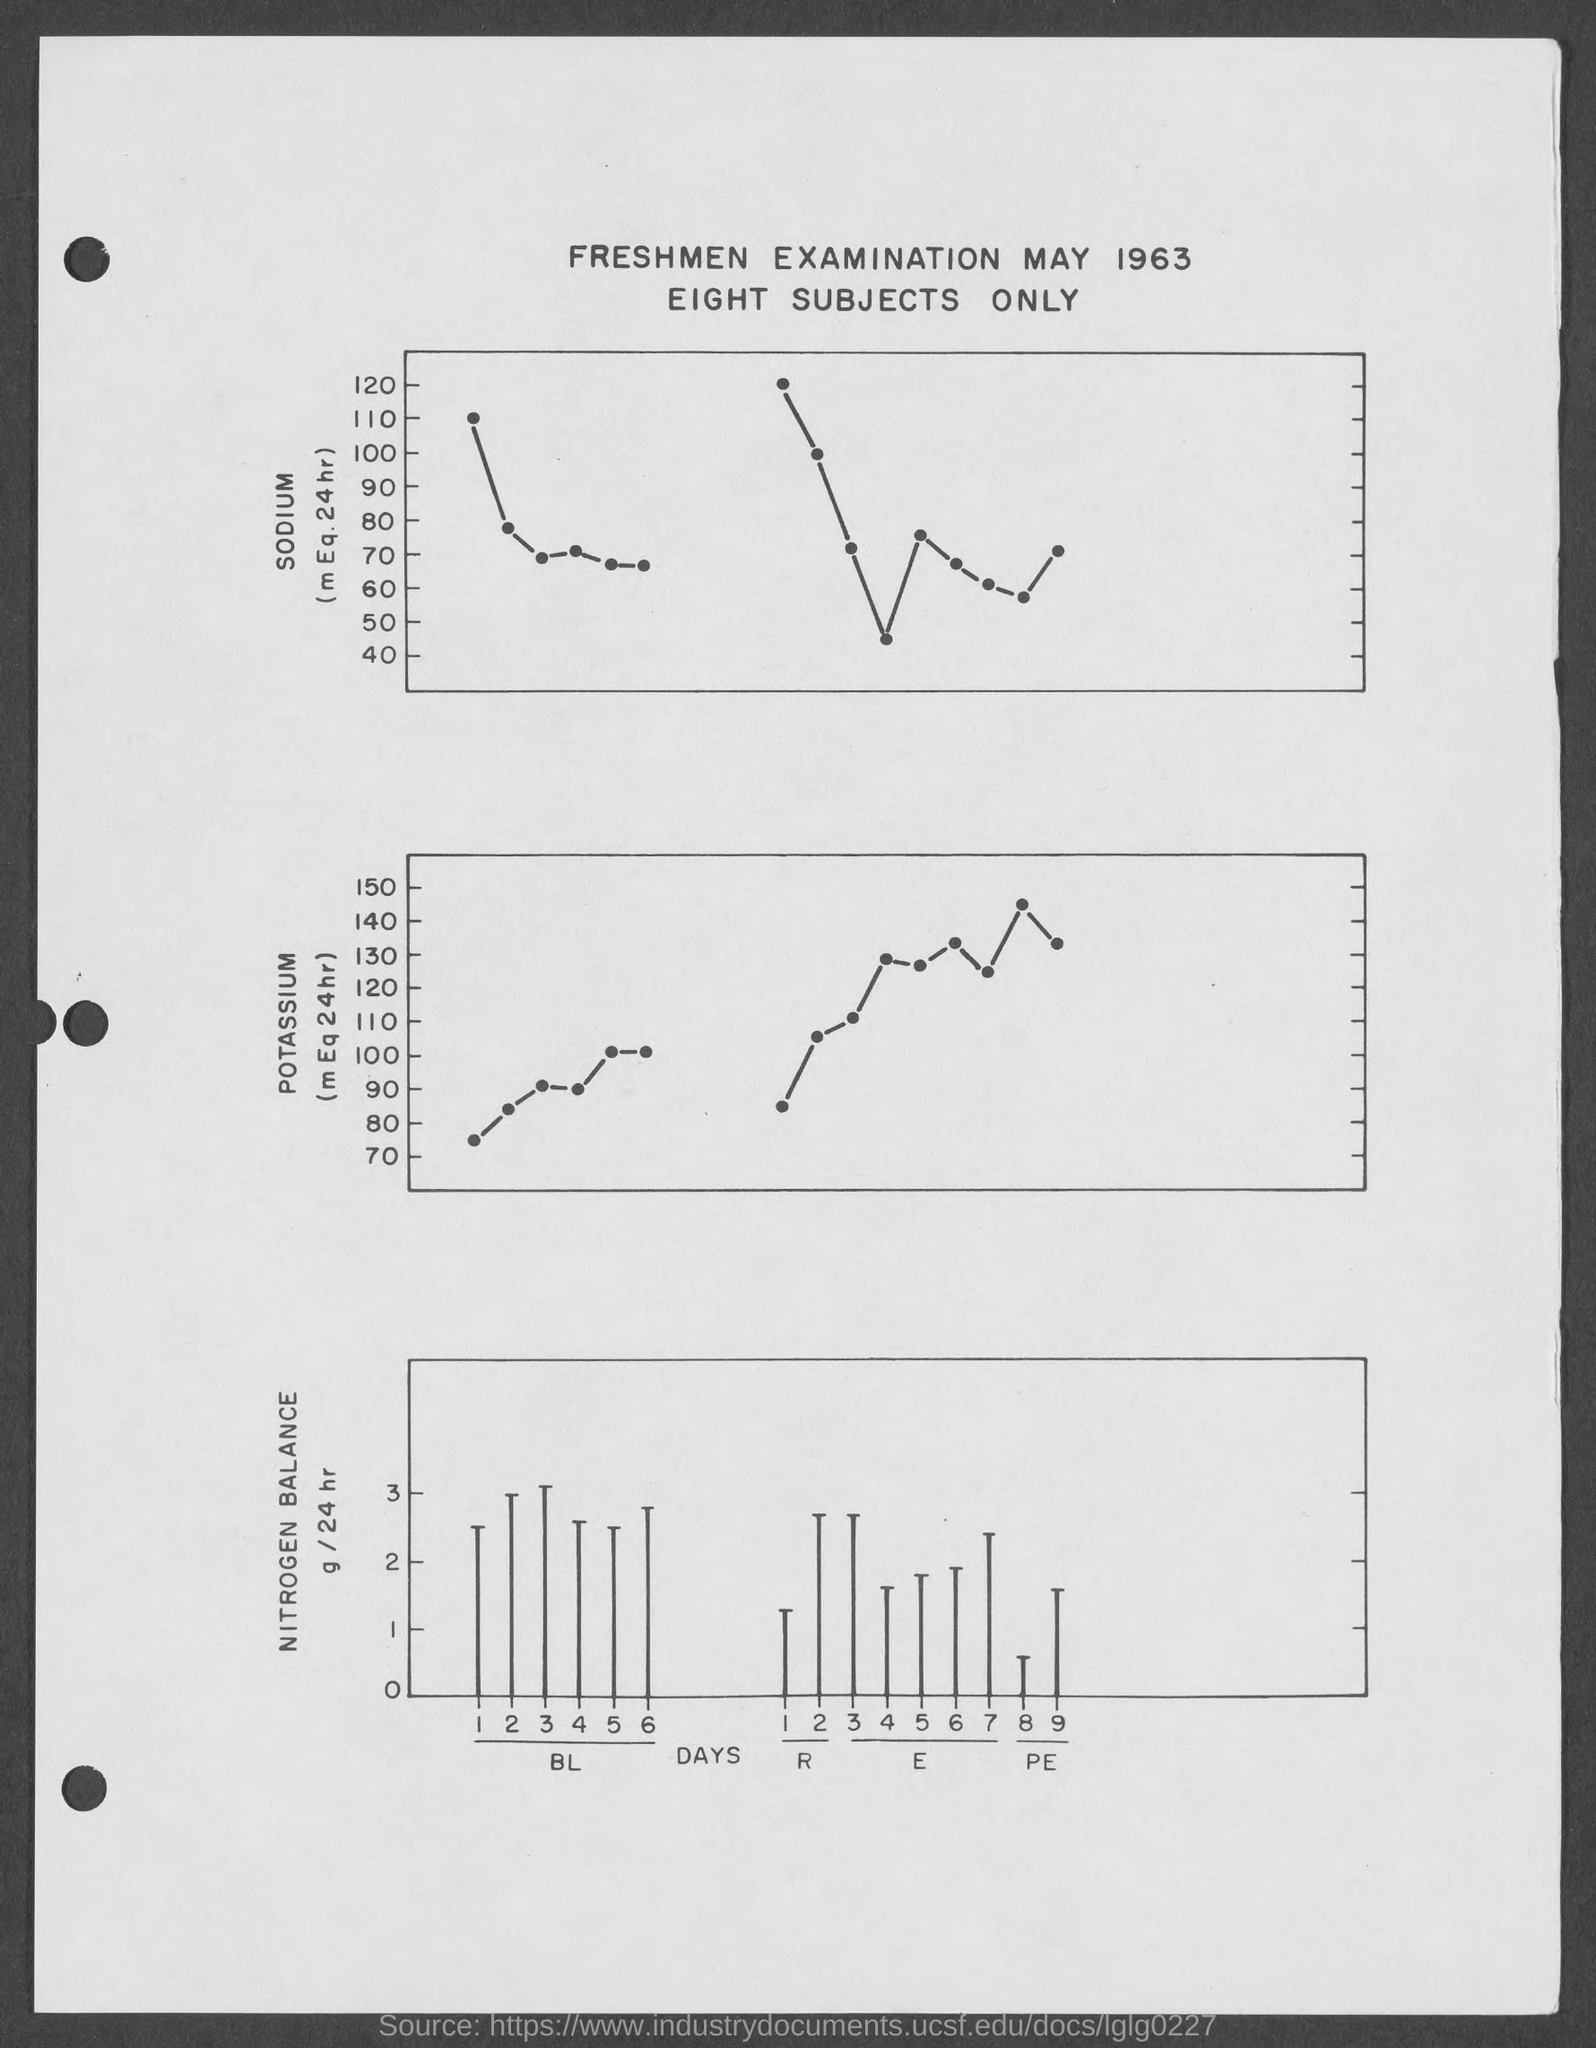Indicate a few pertinent items in this graphic. The freshmen examination will take place on May 1963. There are only eight subjects in total. 